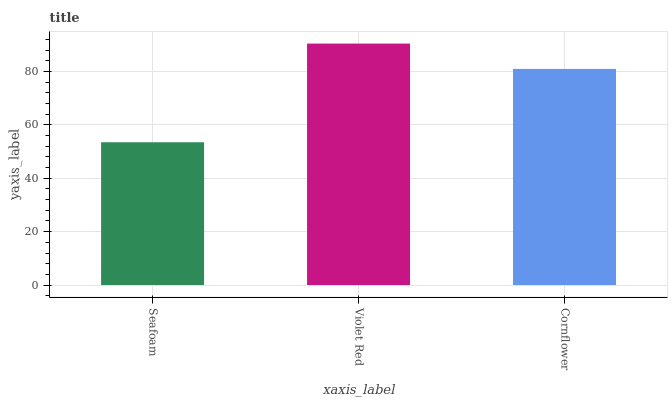Is Seafoam the minimum?
Answer yes or no. Yes. Is Violet Red the maximum?
Answer yes or no. Yes. Is Cornflower the minimum?
Answer yes or no. No. Is Cornflower the maximum?
Answer yes or no. No. Is Violet Red greater than Cornflower?
Answer yes or no. Yes. Is Cornflower less than Violet Red?
Answer yes or no. Yes. Is Cornflower greater than Violet Red?
Answer yes or no. No. Is Violet Red less than Cornflower?
Answer yes or no. No. Is Cornflower the high median?
Answer yes or no. Yes. Is Cornflower the low median?
Answer yes or no. Yes. Is Violet Red the high median?
Answer yes or no. No. Is Seafoam the low median?
Answer yes or no. No. 